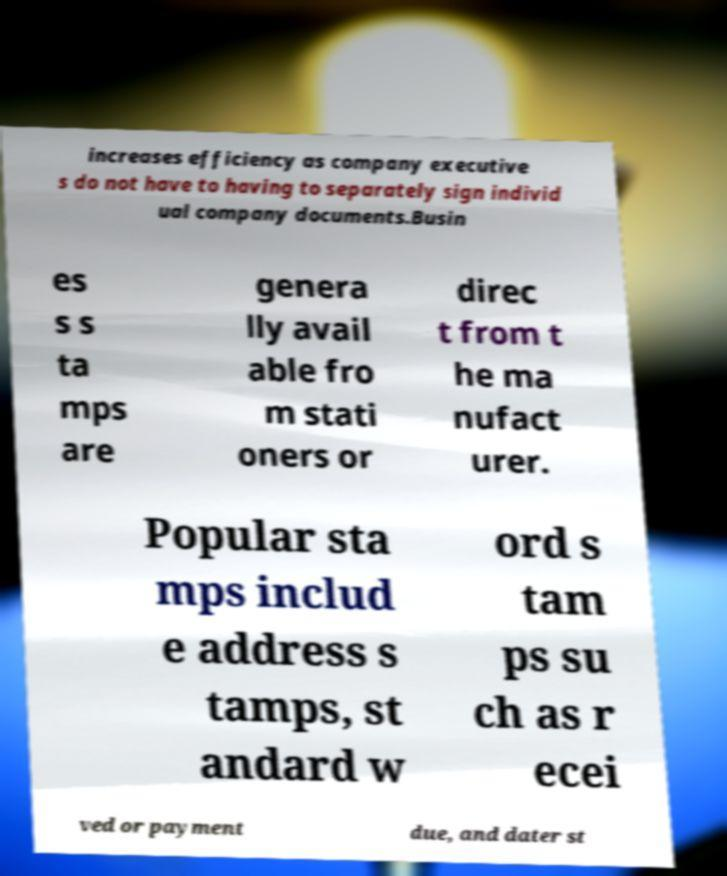Please read and relay the text visible in this image. What does it say? increases efficiency as company executive s do not have to having to separately sign individ ual company documents.Busin es s s ta mps are genera lly avail able fro m stati oners or direc t from t he ma nufact urer. Popular sta mps includ e address s tamps, st andard w ord s tam ps su ch as r ecei ved or payment due, and dater st 